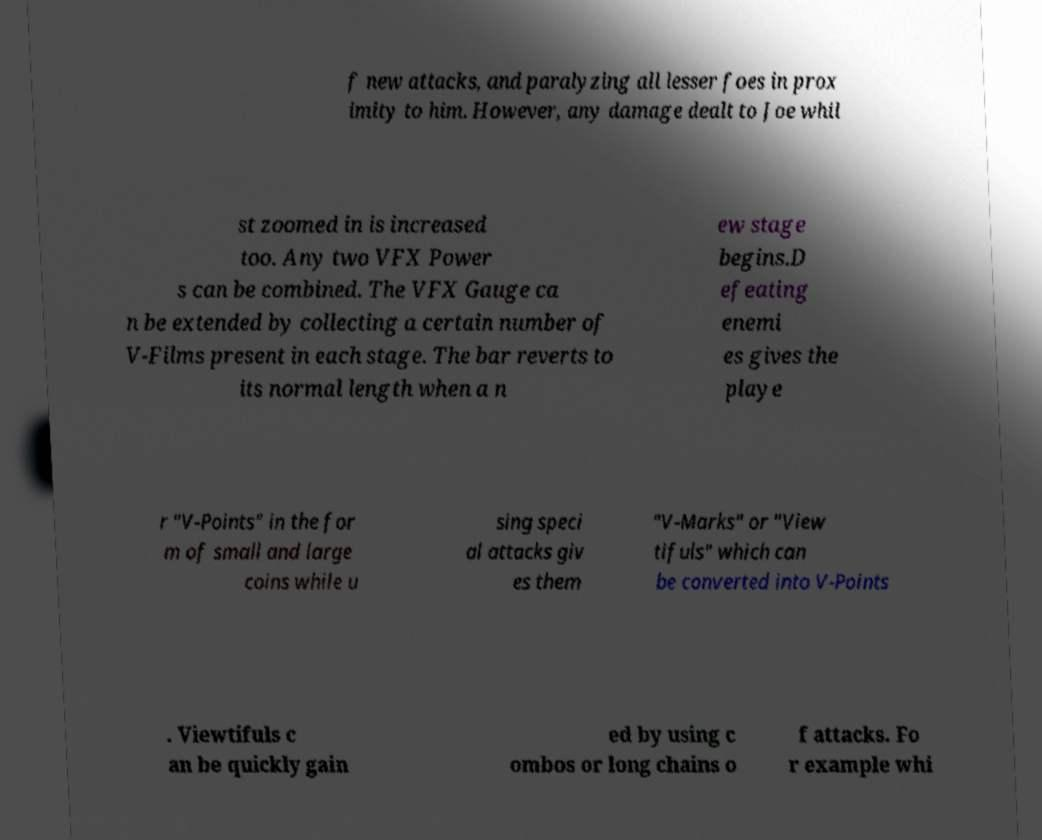Please identify and transcribe the text found in this image. f new attacks, and paralyzing all lesser foes in prox imity to him. However, any damage dealt to Joe whil st zoomed in is increased too. Any two VFX Power s can be combined. The VFX Gauge ca n be extended by collecting a certain number of V-Films present in each stage. The bar reverts to its normal length when a n ew stage begins.D efeating enemi es gives the playe r "V-Points" in the for m of small and large coins while u sing speci al attacks giv es them "V-Marks" or "View tifuls" which can be converted into V-Points . Viewtifuls c an be quickly gain ed by using c ombos or long chains o f attacks. Fo r example whi 